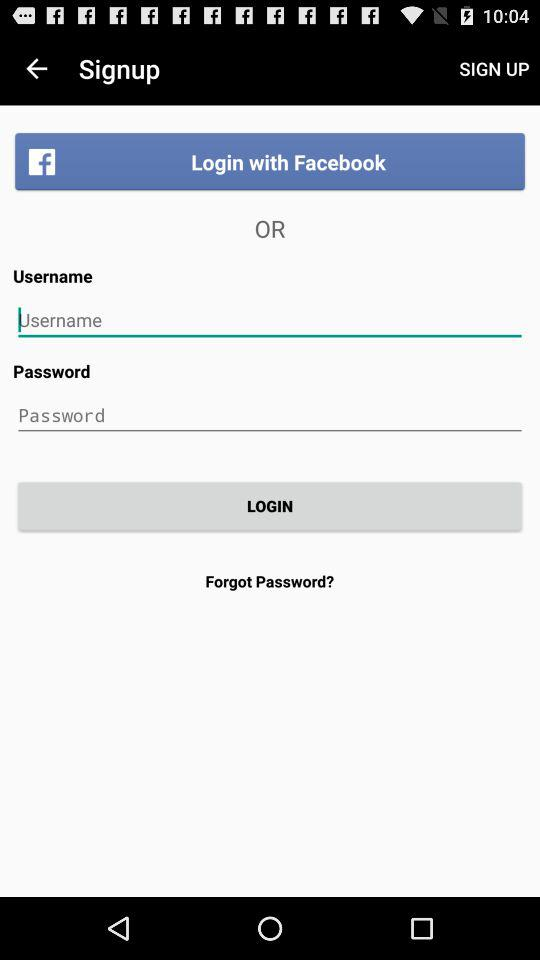How many login options are there?
Answer the question using a single word or phrase. 2 